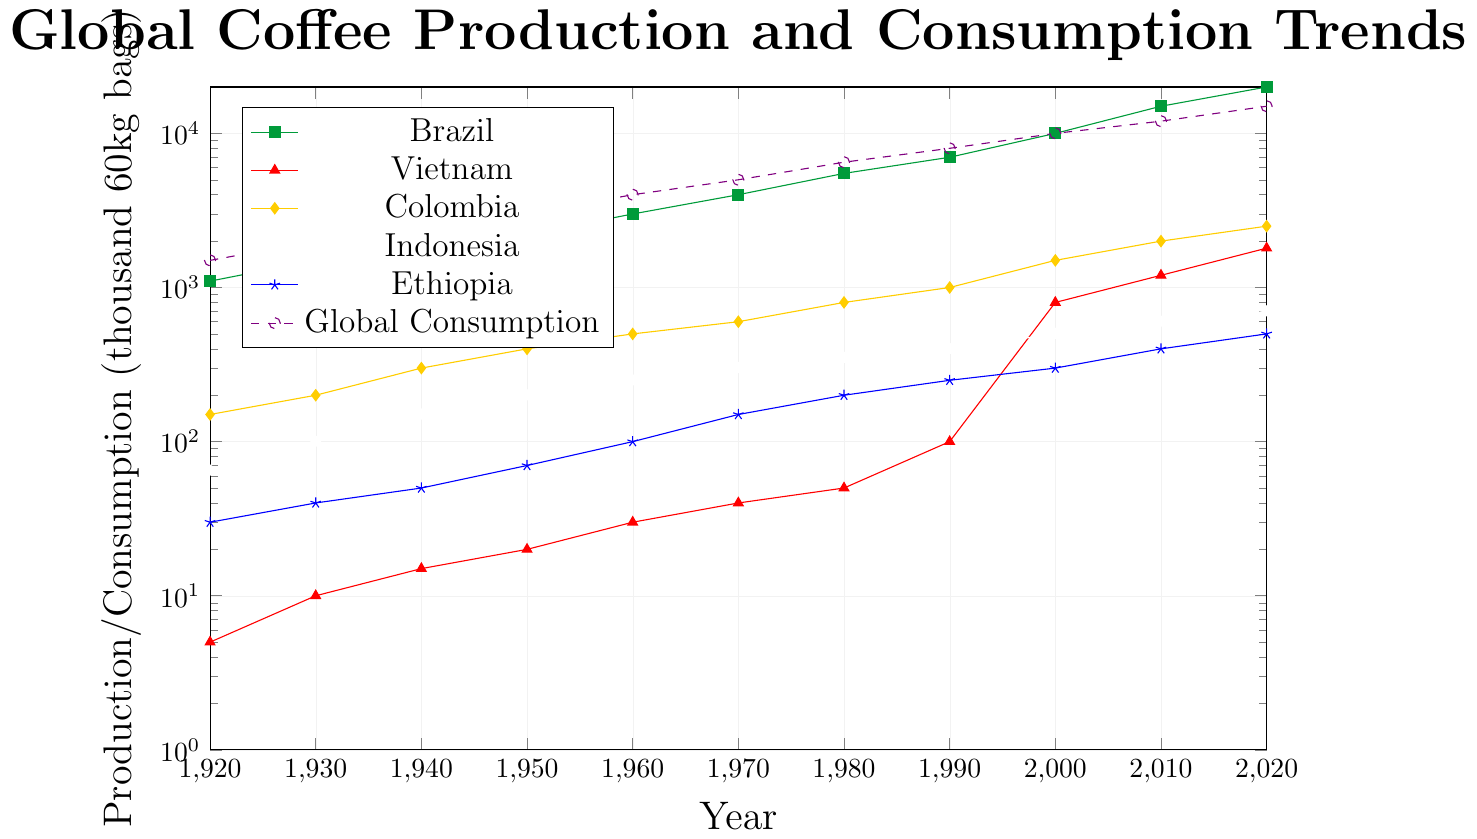What is the highest coffee production value in Brazil over the given years? By referring to the figure, we can see that Brazil's coffee production has been increasing over the years. The highest value is in the year 2020, where it reaches 20000 thousand 60kg bags.
Answer: 20000 How does Vietnam's coffee production in 2000 compare to its production in 1990? In 2000, Vietnam's coffee production is at 800 thousand 60kg bags, while in 1990, it is at 100 thousand 60kg bags. Clearly, the production in 2000 is significantly higher than in 1990.
Answer: 800 > 100 What is the difference in coffee production between Ethiopia and Indonesia in the year 2020? By looking at the figure, in 2020, Ethiopia's coffee production is 500 thousand 60kg bags, and Indonesia's is 700 thousand 60kg bags. The difference between them is 700 - 500 = 200.
Answer: 200 Which country shows the fastest growth in coffee production from 1920 to 2020? Vietnam shows the fastest growth in coffee production, starting from 5 thousand 60kg bags in 1920 and reaching 1800 thousand 60kg bags in 2020. This growth is faster than any other country's.
Answer: Vietnam What is the average coffee production of Colombia from 1950 to 2000? The coffee production in Colombia from 1950 to 2000 are as follows: 400, 500, 600, 800, and 1000 thousand 60kg bags. Sum these values: 400+500+600+800+1000 = 3300. The average is 3300 / 5 = 660.
Answer: 660 Between which consecutive decades does global coffee consumption first exceed 10000 thousand 60kg bags? In the graph, global coffee consumption first surpasses 10000 thousand 60kg bags between 1990 and 2000. In 1990, it is at 8000, and by 2000 it reaches 10000.
Answer: 1990-2000 How does Colombia's coffee production in 1960 compare to Ethiopia's coffee production in 1920? In 1960, Colombia's coffee production is 500 thousand 60kg bags, while Ethiopia's production in 1920 is 30 thousand 60kg bags. Therefore, Colombia's production in 1960 is significantly higher.
Answer: 500 > 30 What is the difference in the production of Brazil and Vietnam in the year 1920? In 1920, Brazil's coffee production is 1100 thousand 60kg bags and Vietnam's production is 5 thousand 60kg bags. The difference between them is 1100 - 5 = 1095.
Answer: 1095 